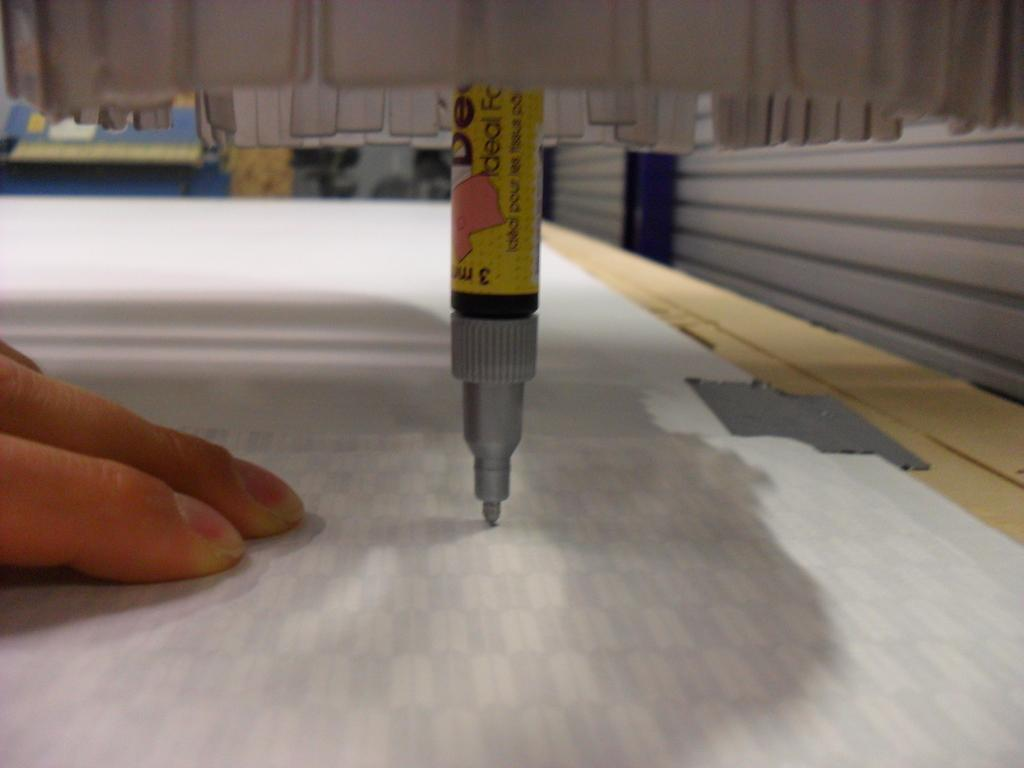<image>
Relay a brief, clear account of the picture shown. A stationary marker with the word Ideal on it is being used to make patterns on a piece of paper. 